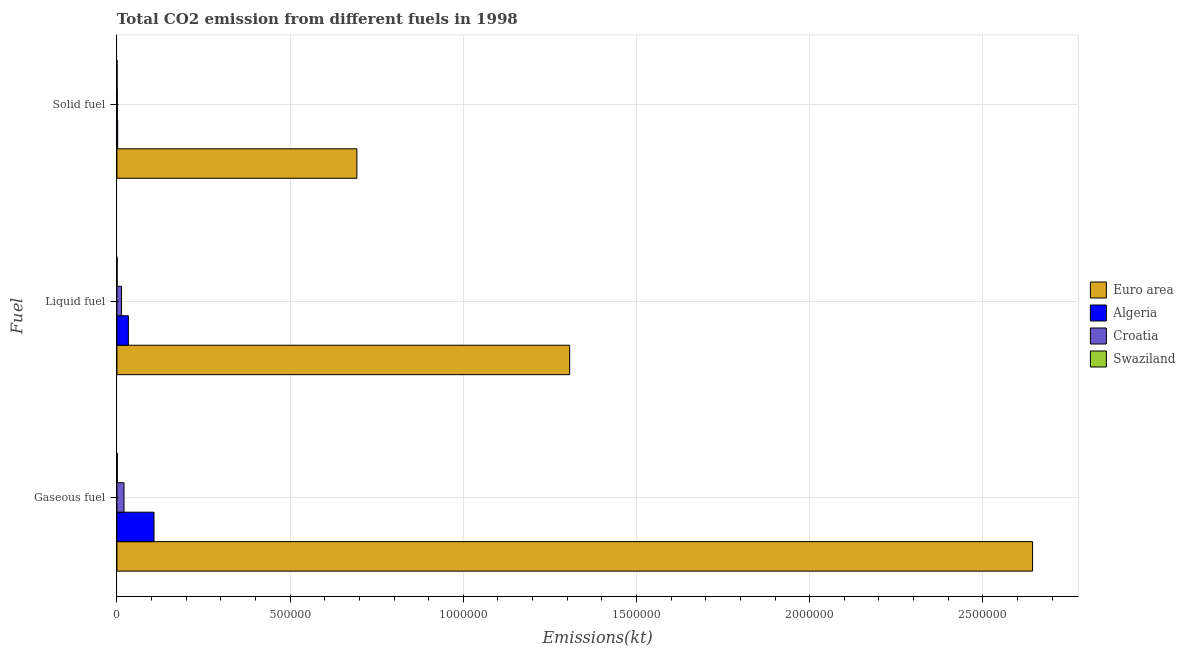How many different coloured bars are there?
Your response must be concise. 4. What is the label of the 3rd group of bars from the top?
Provide a succinct answer. Gaseous fuel. What is the amount of co2 emissions from solid fuel in Croatia?
Offer a very short reply. 1052.43. Across all countries, what is the maximum amount of co2 emissions from liquid fuel?
Give a very brief answer. 1.31e+06. Across all countries, what is the minimum amount of co2 emissions from solid fuel?
Make the answer very short. 564.72. In which country was the amount of co2 emissions from liquid fuel minimum?
Keep it short and to the point. Swaziland. What is the total amount of co2 emissions from gaseous fuel in the graph?
Provide a short and direct response. 2.77e+06. What is the difference between the amount of co2 emissions from gaseous fuel in Algeria and that in Euro area?
Offer a terse response. -2.54e+06. What is the difference between the amount of co2 emissions from solid fuel in Croatia and the amount of co2 emissions from liquid fuel in Algeria?
Offer a terse response. -3.21e+04. What is the average amount of co2 emissions from liquid fuel per country?
Make the answer very short. 3.39e+05. What is the difference between the amount of co2 emissions from gaseous fuel and amount of co2 emissions from solid fuel in Euro area?
Your response must be concise. 1.95e+06. What is the ratio of the amount of co2 emissions from liquid fuel in Euro area to that in Croatia?
Ensure brevity in your answer.  98.49. Is the amount of co2 emissions from gaseous fuel in Croatia less than that in Swaziland?
Provide a succinct answer. No. What is the difference between the highest and the second highest amount of co2 emissions from gaseous fuel?
Provide a short and direct response. 2.54e+06. What is the difference between the highest and the lowest amount of co2 emissions from solid fuel?
Offer a terse response. 6.92e+05. In how many countries, is the amount of co2 emissions from liquid fuel greater than the average amount of co2 emissions from liquid fuel taken over all countries?
Ensure brevity in your answer.  1. Is the sum of the amount of co2 emissions from solid fuel in Croatia and Algeria greater than the maximum amount of co2 emissions from liquid fuel across all countries?
Keep it short and to the point. No. What does the 1st bar from the top in Liquid fuel represents?
Give a very brief answer. Swaziland. Is it the case that in every country, the sum of the amount of co2 emissions from gaseous fuel and amount of co2 emissions from liquid fuel is greater than the amount of co2 emissions from solid fuel?
Your answer should be very brief. Yes. How many bars are there?
Your answer should be compact. 12. How many countries are there in the graph?
Your answer should be very brief. 4. What is the difference between two consecutive major ticks on the X-axis?
Offer a very short reply. 5.00e+05. Does the graph contain grids?
Offer a very short reply. Yes. Where does the legend appear in the graph?
Give a very brief answer. Center right. How many legend labels are there?
Offer a very short reply. 4. How are the legend labels stacked?
Provide a succinct answer. Vertical. What is the title of the graph?
Provide a succinct answer. Total CO2 emission from different fuels in 1998. What is the label or title of the X-axis?
Provide a short and direct response. Emissions(kt). What is the label or title of the Y-axis?
Your response must be concise. Fuel. What is the Emissions(kt) in Euro area in Gaseous fuel?
Offer a very short reply. 2.64e+06. What is the Emissions(kt) of Algeria in Gaseous fuel?
Your response must be concise. 1.07e+05. What is the Emissions(kt) of Croatia in Gaseous fuel?
Make the answer very short. 2.04e+04. What is the Emissions(kt) of Swaziland in Gaseous fuel?
Your answer should be very brief. 1213.78. What is the Emissions(kt) of Euro area in Liquid fuel?
Give a very brief answer. 1.31e+06. What is the Emissions(kt) of Algeria in Liquid fuel?
Provide a succinct answer. 3.31e+04. What is the Emissions(kt) of Croatia in Liquid fuel?
Make the answer very short. 1.33e+04. What is the Emissions(kt) in Swaziland in Liquid fuel?
Your answer should be very brief. 649.06. What is the Emissions(kt) in Euro area in Solid fuel?
Offer a terse response. 6.93e+05. What is the Emissions(kt) of Algeria in Solid fuel?
Your answer should be very brief. 2192.87. What is the Emissions(kt) in Croatia in Solid fuel?
Give a very brief answer. 1052.43. What is the Emissions(kt) in Swaziland in Solid fuel?
Make the answer very short. 564.72. Across all Fuel, what is the maximum Emissions(kt) of Euro area?
Offer a terse response. 2.64e+06. Across all Fuel, what is the maximum Emissions(kt) in Algeria?
Give a very brief answer. 1.07e+05. Across all Fuel, what is the maximum Emissions(kt) in Croatia?
Make the answer very short. 2.04e+04. Across all Fuel, what is the maximum Emissions(kt) of Swaziland?
Provide a succinct answer. 1213.78. Across all Fuel, what is the minimum Emissions(kt) of Euro area?
Your answer should be compact. 6.93e+05. Across all Fuel, what is the minimum Emissions(kt) of Algeria?
Offer a very short reply. 2192.87. Across all Fuel, what is the minimum Emissions(kt) of Croatia?
Provide a succinct answer. 1052.43. Across all Fuel, what is the minimum Emissions(kt) in Swaziland?
Make the answer very short. 564.72. What is the total Emissions(kt) in Euro area in the graph?
Offer a very short reply. 4.64e+06. What is the total Emissions(kt) of Algeria in the graph?
Your answer should be very brief. 1.42e+05. What is the total Emissions(kt) in Croatia in the graph?
Provide a short and direct response. 3.47e+04. What is the total Emissions(kt) of Swaziland in the graph?
Keep it short and to the point. 2427.55. What is the difference between the Emissions(kt) of Euro area in Gaseous fuel and that in Liquid fuel?
Your answer should be very brief. 1.34e+06. What is the difference between the Emissions(kt) in Algeria in Gaseous fuel and that in Liquid fuel?
Ensure brevity in your answer.  7.40e+04. What is the difference between the Emissions(kt) of Croatia in Gaseous fuel and that in Liquid fuel?
Provide a short and direct response. 7146.98. What is the difference between the Emissions(kt) of Swaziland in Gaseous fuel and that in Liquid fuel?
Give a very brief answer. 564.72. What is the difference between the Emissions(kt) of Euro area in Gaseous fuel and that in Solid fuel?
Your response must be concise. 1.95e+06. What is the difference between the Emissions(kt) in Algeria in Gaseous fuel and that in Solid fuel?
Your response must be concise. 1.05e+05. What is the difference between the Emissions(kt) in Croatia in Gaseous fuel and that in Solid fuel?
Your response must be concise. 1.94e+04. What is the difference between the Emissions(kt) of Swaziland in Gaseous fuel and that in Solid fuel?
Your answer should be compact. 649.06. What is the difference between the Emissions(kt) in Euro area in Liquid fuel and that in Solid fuel?
Your response must be concise. 6.14e+05. What is the difference between the Emissions(kt) of Algeria in Liquid fuel and that in Solid fuel?
Your answer should be very brief. 3.09e+04. What is the difference between the Emissions(kt) in Croatia in Liquid fuel and that in Solid fuel?
Your response must be concise. 1.22e+04. What is the difference between the Emissions(kt) of Swaziland in Liquid fuel and that in Solid fuel?
Keep it short and to the point. 84.34. What is the difference between the Emissions(kt) of Euro area in Gaseous fuel and the Emissions(kt) of Algeria in Liquid fuel?
Offer a very short reply. 2.61e+06. What is the difference between the Emissions(kt) of Euro area in Gaseous fuel and the Emissions(kt) of Croatia in Liquid fuel?
Offer a very short reply. 2.63e+06. What is the difference between the Emissions(kt) in Euro area in Gaseous fuel and the Emissions(kt) in Swaziland in Liquid fuel?
Make the answer very short. 2.64e+06. What is the difference between the Emissions(kt) in Algeria in Gaseous fuel and the Emissions(kt) in Croatia in Liquid fuel?
Your answer should be compact. 9.38e+04. What is the difference between the Emissions(kt) of Algeria in Gaseous fuel and the Emissions(kt) of Swaziland in Liquid fuel?
Keep it short and to the point. 1.06e+05. What is the difference between the Emissions(kt) in Croatia in Gaseous fuel and the Emissions(kt) in Swaziland in Liquid fuel?
Offer a terse response. 1.98e+04. What is the difference between the Emissions(kt) in Euro area in Gaseous fuel and the Emissions(kt) in Algeria in Solid fuel?
Offer a very short reply. 2.64e+06. What is the difference between the Emissions(kt) of Euro area in Gaseous fuel and the Emissions(kt) of Croatia in Solid fuel?
Offer a very short reply. 2.64e+06. What is the difference between the Emissions(kt) in Euro area in Gaseous fuel and the Emissions(kt) in Swaziland in Solid fuel?
Offer a terse response. 2.64e+06. What is the difference between the Emissions(kt) in Algeria in Gaseous fuel and the Emissions(kt) in Croatia in Solid fuel?
Provide a succinct answer. 1.06e+05. What is the difference between the Emissions(kt) in Algeria in Gaseous fuel and the Emissions(kt) in Swaziland in Solid fuel?
Give a very brief answer. 1.07e+05. What is the difference between the Emissions(kt) of Croatia in Gaseous fuel and the Emissions(kt) of Swaziland in Solid fuel?
Your response must be concise. 1.99e+04. What is the difference between the Emissions(kt) of Euro area in Liquid fuel and the Emissions(kt) of Algeria in Solid fuel?
Provide a short and direct response. 1.30e+06. What is the difference between the Emissions(kt) of Euro area in Liquid fuel and the Emissions(kt) of Croatia in Solid fuel?
Give a very brief answer. 1.31e+06. What is the difference between the Emissions(kt) in Euro area in Liquid fuel and the Emissions(kt) in Swaziland in Solid fuel?
Provide a short and direct response. 1.31e+06. What is the difference between the Emissions(kt) of Algeria in Liquid fuel and the Emissions(kt) of Croatia in Solid fuel?
Offer a terse response. 3.21e+04. What is the difference between the Emissions(kt) of Algeria in Liquid fuel and the Emissions(kt) of Swaziland in Solid fuel?
Make the answer very short. 3.26e+04. What is the difference between the Emissions(kt) in Croatia in Liquid fuel and the Emissions(kt) in Swaziland in Solid fuel?
Your answer should be compact. 1.27e+04. What is the average Emissions(kt) of Euro area per Fuel?
Your answer should be compact. 1.55e+06. What is the average Emissions(kt) in Algeria per Fuel?
Offer a very short reply. 4.75e+04. What is the average Emissions(kt) of Croatia per Fuel?
Provide a succinct answer. 1.16e+04. What is the average Emissions(kt) in Swaziland per Fuel?
Provide a short and direct response. 809.18. What is the difference between the Emissions(kt) in Euro area and Emissions(kt) in Algeria in Gaseous fuel?
Give a very brief answer. 2.54e+06. What is the difference between the Emissions(kt) of Euro area and Emissions(kt) of Croatia in Gaseous fuel?
Offer a very short reply. 2.62e+06. What is the difference between the Emissions(kt) of Euro area and Emissions(kt) of Swaziland in Gaseous fuel?
Keep it short and to the point. 2.64e+06. What is the difference between the Emissions(kt) in Algeria and Emissions(kt) in Croatia in Gaseous fuel?
Your answer should be very brief. 8.67e+04. What is the difference between the Emissions(kt) in Algeria and Emissions(kt) in Swaziland in Gaseous fuel?
Provide a short and direct response. 1.06e+05. What is the difference between the Emissions(kt) in Croatia and Emissions(kt) in Swaziland in Gaseous fuel?
Your answer should be very brief. 1.92e+04. What is the difference between the Emissions(kt) of Euro area and Emissions(kt) of Algeria in Liquid fuel?
Make the answer very short. 1.27e+06. What is the difference between the Emissions(kt) in Euro area and Emissions(kt) in Croatia in Liquid fuel?
Offer a terse response. 1.29e+06. What is the difference between the Emissions(kt) of Euro area and Emissions(kt) of Swaziland in Liquid fuel?
Make the answer very short. 1.31e+06. What is the difference between the Emissions(kt) of Algeria and Emissions(kt) of Croatia in Liquid fuel?
Provide a succinct answer. 1.98e+04. What is the difference between the Emissions(kt) in Algeria and Emissions(kt) in Swaziland in Liquid fuel?
Offer a terse response. 3.25e+04. What is the difference between the Emissions(kt) in Croatia and Emissions(kt) in Swaziland in Liquid fuel?
Make the answer very short. 1.26e+04. What is the difference between the Emissions(kt) in Euro area and Emissions(kt) in Algeria in Solid fuel?
Offer a very short reply. 6.91e+05. What is the difference between the Emissions(kt) in Euro area and Emissions(kt) in Croatia in Solid fuel?
Your response must be concise. 6.92e+05. What is the difference between the Emissions(kt) of Euro area and Emissions(kt) of Swaziland in Solid fuel?
Your response must be concise. 6.92e+05. What is the difference between the Emissions(kt) of Algeria and Emissions(kt) of Croatia in Solid fuel?
Keep it short and to the point. 1140.44. What is the difference between the Emissions(kt) of Algeria and Emissions(kt) of Swaziland in Solid fuel?
Your response must be concise. 1628.15. What is the difference between the Emissions(kt) of Croatia and Emissions(kt) of Swaziland in Solid fuel?
Offer a terse response. 487.71. What is the ratio of the Emissions(kt) in Euro area in Gaseous fuel to that in Liquid fuel?
Provide a succinct answer. 2.02. What is the ratio of the Emissions(kt) of Algeria in Gaseous fuel to that in Liquid fuel?
Your answer should be compact. 3.23. What is the ratio of the Emissions(kt) in Croatia in Gaseous fuel to that in Liquid fuel?
Your answer should be very brief. 1.54. What is the ratio of the Emissions(kt) of Swaziland in Gaseous fuel to that in Liquid fuel?
Ensure brevity in your answer.  1.87. What is the ratio of the Emissions(kt) of Euro area in Gaseous fuel to that in Solid fuel?
Ensure brevity in your answer.  3.82. What is the ratio of the Emissions(kt) in Algeria in Gaseous fuel to that in Solid fuel?
Provide a succinct answer. 48.83. What is the ratio of the Emissions(kt) in Croatia in Gaseous fuel to that in Solid fuel?
Your answer should be compact. 19.4. What is the ratio of the Emissions(kt) in Swaziland in Gaseous fuel to that in Solid fuel?
Your response must be concise. 2.15. What is the ratio of the Emissions(kt) of Euro area in Liquid fuel to that in Solid fuel?
Ensure brevity in your answer.  1.89. What is the ratio of the Emissions(kt) in Algeria in Liquid fuel to that in Solid fuel?
Your answer should be very brief. 15.1. What is the ratio of the Emissions(kt) of Croatia in Liquid fuel to that in Solid fuel?
Keep it short and to the point. 12.61. What is the ratio of the Emissions(kt) in Swaziland in Liquid fuel to that in Solid fuel?
Provide a succinct answer. 1.15. What is the difference between the highest and the second highest Emissions(kt) in Euro area?
Your response must be concise. 1.34e+06. What is the difference between the highest and the second highest Emissions(kt) in Algeria?
Offer a terse response. 7.40e+04. What is the difference between the highest and the second highest Emissions(kt) of Croatia?
Ensure brevity in your answer.  7146.98. What is the difference between the highest and the second highest Emissions(kt) in Swaziland?
Provide a succinct answer. 564.72. What is the difference between the highest and the lowest Emissions(kt) in Euro area?
Make the answer very short. 1.95e+06. What is the difference between the highest and the lowest Emissions(kt) of Algeria?
Your answer should be very brief. 1.05e+05. What is the difference between the highest and the lowest Emissions(kt) of Croatia?
Give a very brief answer. 1.94e+04. What is the difference between the highest and the lowest Emissions(kt) in Swaziland?
Provide a succinct answer. 649.06. 